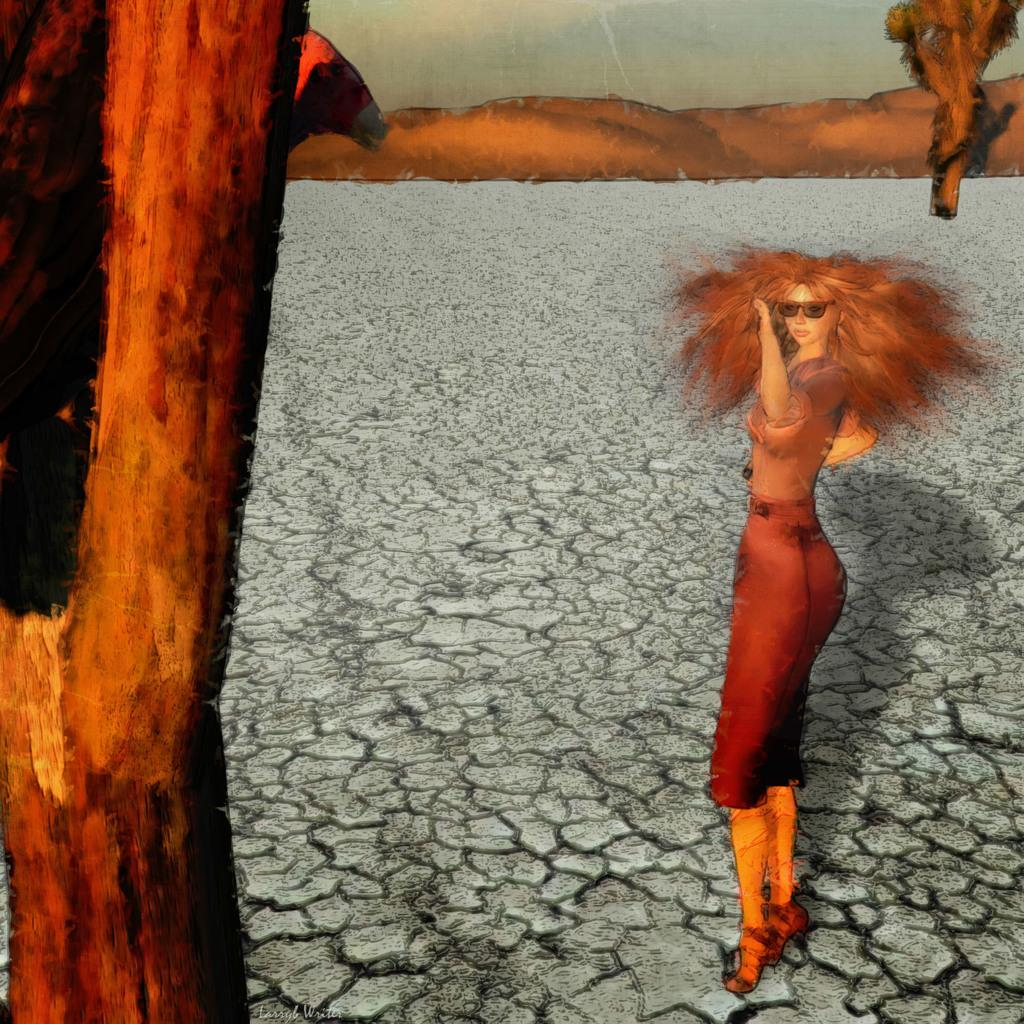What type of image is being described? The image appears to be an animation. Can you describe the woman in the image? There is a woman on the right side of the image, and she is standing. What can be seen in the background of the image? The sky is visible at the top of the image. What type of leg is being served in the stew in the image? There is no stew or leg present in the image; it features an animated scene with a woman standing. 